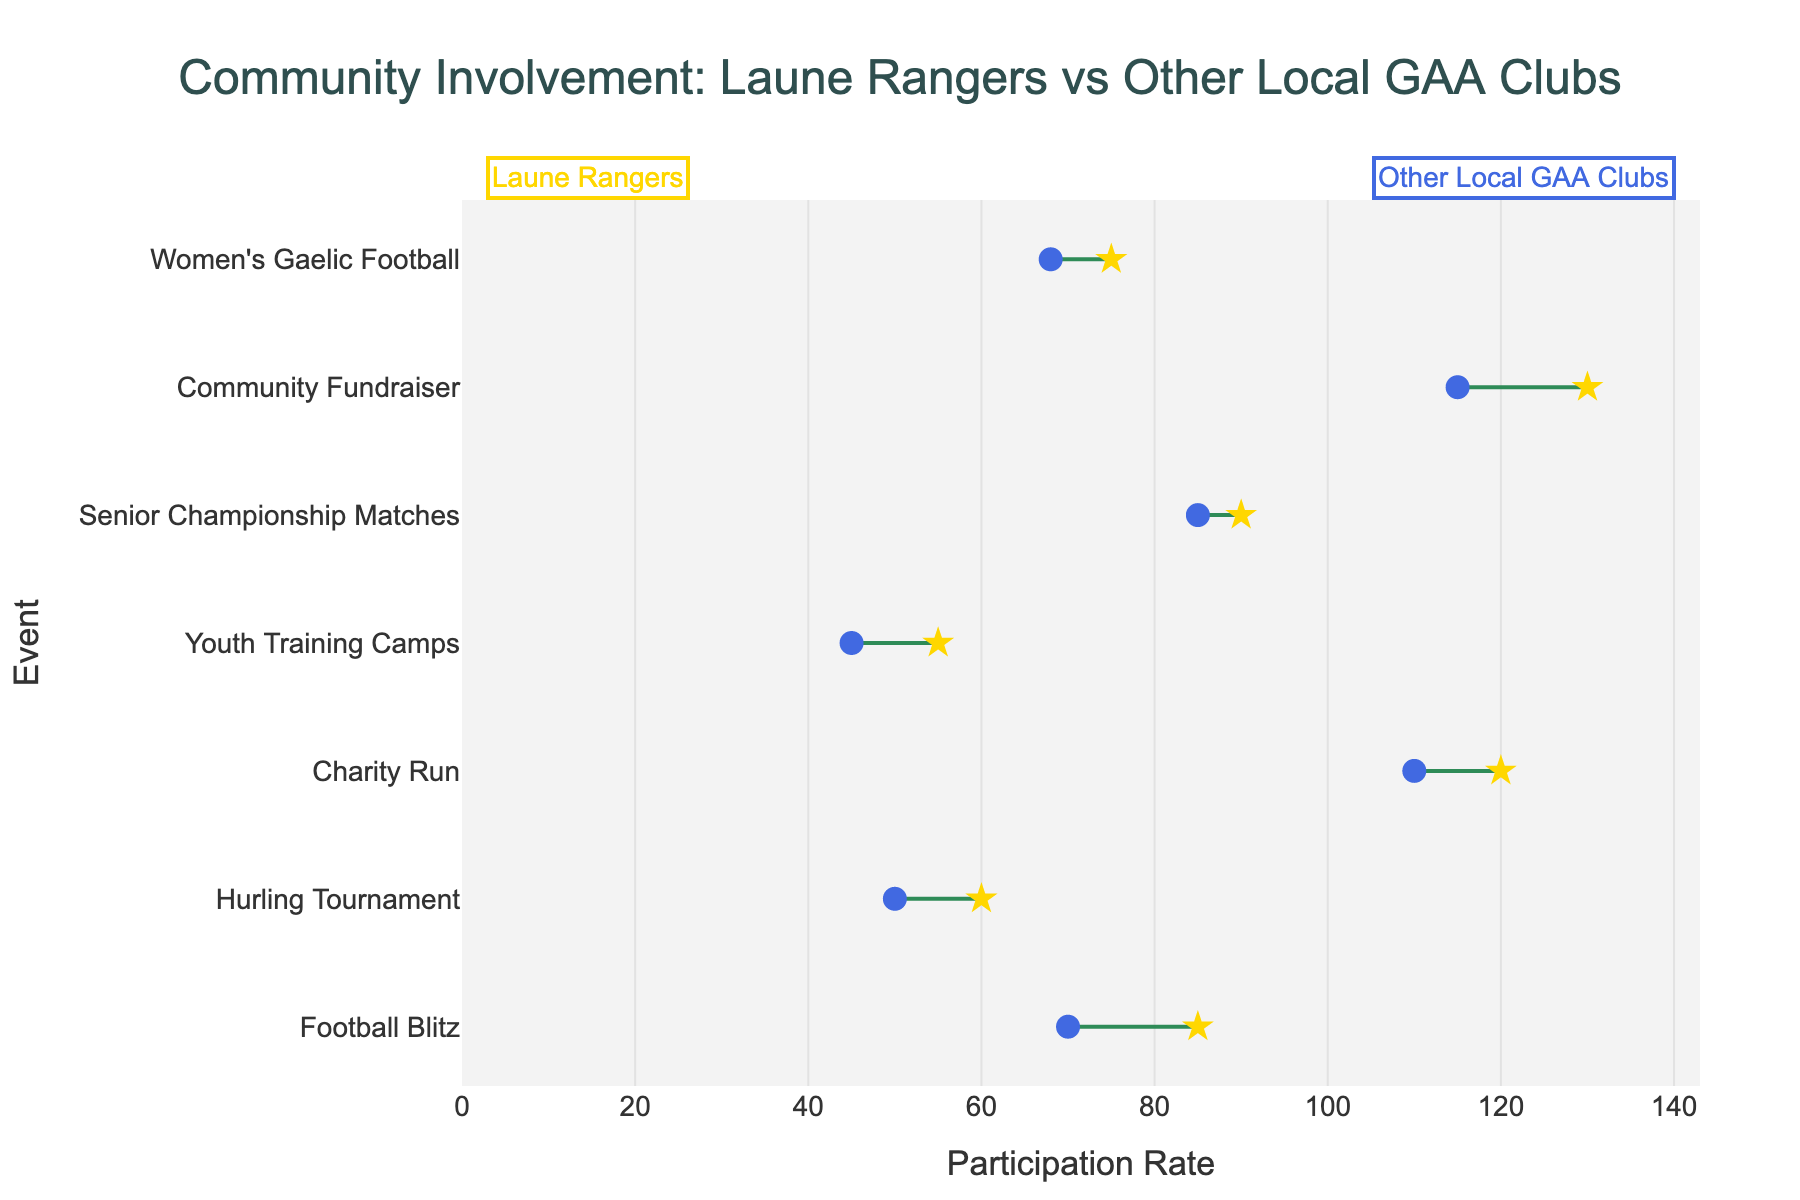What's the title of the plot? The title is displayed at the top of the plot, allowing the viewer to quickly understand the topic. The title reads "Community Involvement: Laune Rangers vs Other Local GAA Clubs".
Answer: Community Involvement: Laune Rangers vs Other Local GAA Clubs How many events are compared in the plot? By counting the number of unique labels on the y-axis, we can determine that there are seven events compared in the plot.
Answer: Seven Which event has the highest participation rate for Laune Rangers? The event with the highest participation rate for Laune Rangers can be identified by looking for the maximum value on the x-axis associated with Laune Rangers' markers. The Community Fundraiser shows the highest participation rate at 130.
Answer: Community Fundraiser How many more participants did the Laune Rangers have in the Football Blitz compared to other local GAA clubs? Subtract the participation rate of other local GAA clubs for the Football Blitz (70) from that of Laune Rangers (85). The difference is 85 - 70 = 15.
Answer: 15 Which event shows the smallest difference in participation rates between Laune Rangers and other local GAA clubs? To find the event with the smallest difference, calculate the absolute differences for each event and identify the smallest value. The difference in Senior Championship Matches is 90 - 85 = 5, which is the smallest.
Answer: Senior Championship Matches What is the average participation rate for both groups across all events? Sum the participation rates for both Laune Rangers and other local GAA clubs, then divide by the number of events. Laune Rangers: (85+60+120+55+90+130+75)=615, Other Local GAA Clubs: (70+50+110+45+85+115+68)=543. Average for Laune Rangers: 615/7 ≈ 87.86, Average for Other Local GAA Clubs: 543/7 ≈ 77.57.
Answer: Laune Rangers: ~87.86, Other Local GAA Clubs: ~77.57 Did any event see an equal number of participants from Laune Rangers and other local GAA clubs? To check this, we need to compare the participation rates for both groups in each event. No events have equal participation rates according to the given data.
Answer: No Which group had more participation in the Youth Training Camps? By comparing the participation rates for Youth Training Camps, Laune Rangers had 55 while other local GAA clubs had 45. Therefore, Laune Rangers had more participation.
Answer: Laune Rangers What color represents Laune Rangers in the plot? The color representing Laune Rangers appears next to the markers in the plot. It is golden yellow (often representing stars).
Answer: Golden Yellow How much higher is the total participation rate for Laune Rangers compared to other local GAA clubs across all events? Calculate the total participation rates for both groups and subtract the total for other local GAA clubs from that of Laune Rangers. Total participation for Laune Rangers is 615 and for other local GAA clubs is 543. The difference is 615 - 543 = 72.
Answer: 72 